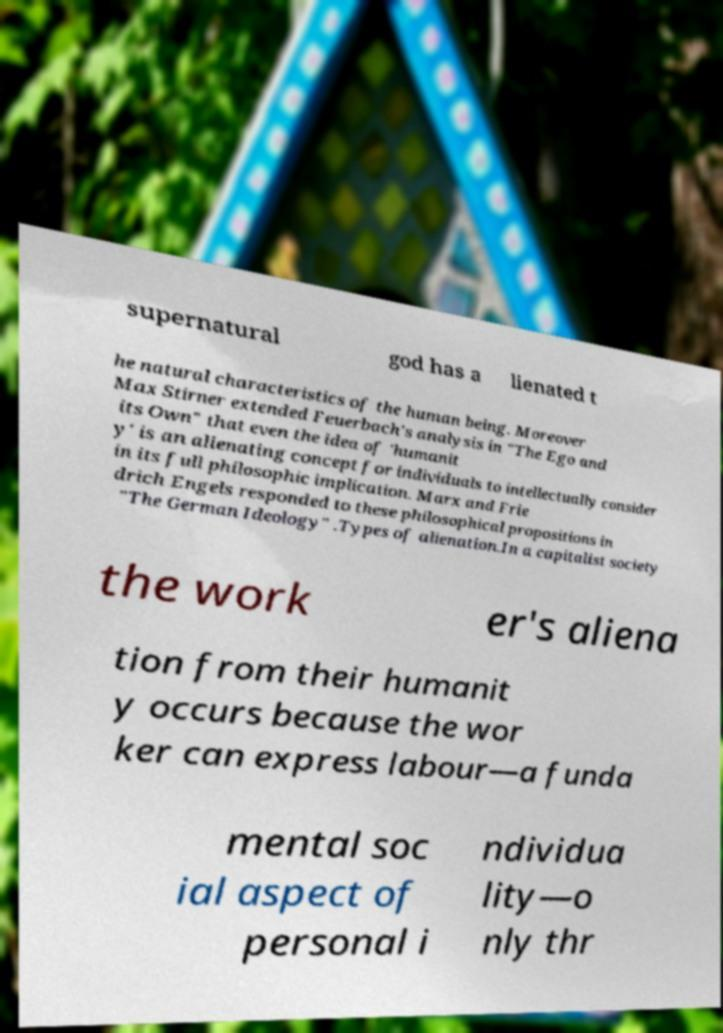For documentation purposes, I need the text within this image transcribed. Could you provide that? supernatural god has a lienated t he natural characteristics of the human being. Moreover Max Stirner extended Feuerbach's analysis in "The Ego and its Own" that even the idea of 'humanit y' is an alienating concept for individuals to intellectually consider in its full philosophic implication. Marx and Frie drich Engels responded to these philosophical propositions in "The German Ideology" .Types of alienation.In a capitalist society the work er's aliena tion from their humanit y occurs because the wor ker can express labour—a funda mental soc ial aspect of personal i ndividua lity—o nly thr 